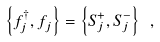Convert formula to latex. <formula><loc_0><loc_0><loc_500><loc_500>\left \{ f _ { j } ^ { \dagger } , f _ { j } ^ { \, } \right \} = \left \{ S _ { j } ^ { + } , S _ { j } ^ { - } \right \} \ ,</formula> 